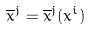Convert formula to latex. <formula><loc_0><loc_0><loc_500><loc_500>\overline { x } ^ { j } = \overline { x } ^ { j } ( x ^ { i } )</formula> 